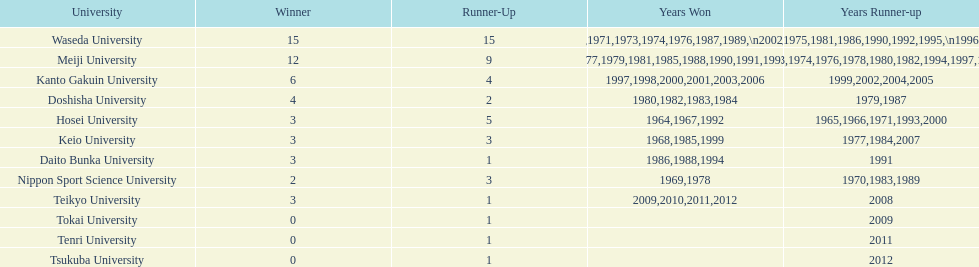At which university were the most years claimed as victories? Waseda University. 